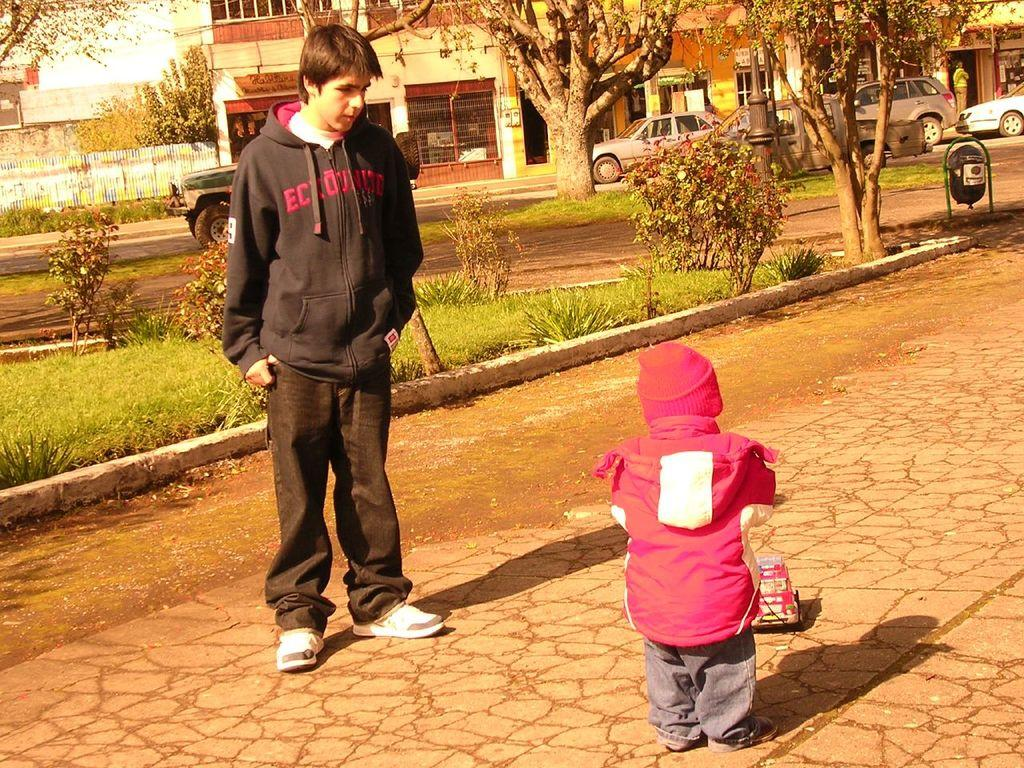Who is present in the image? There is a man and a child in the image. What can be seen on the ground in the image? There is a toy vehicle on the ground in the image. What is visible in the background of the image? There are plants, vehicles, a dustbin, trees, buildings, a person, and some objects in the background of the image. Can you see any hydrants in the image? There are no hydrants visible in the image. Are there any ants crawling on the toy vehicle in the image? There is no indication of ants in the image; the focus is on the man, child, and toy vehicle. 